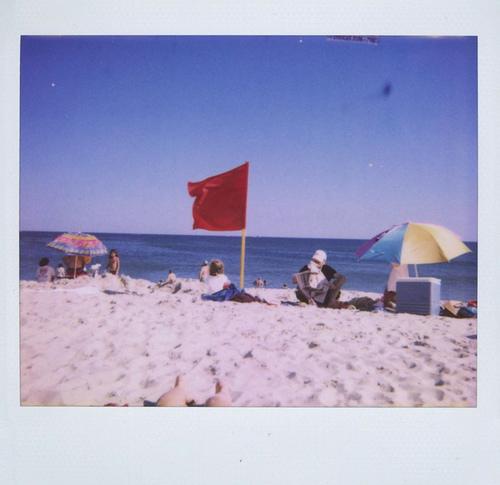Is this area in a market?
Answer briefly. No. Where was this picture taken?
Answer briefly. Beach. Is the dog awake or asleep?
Answer briefly. Awake. What time of the day was this picture taken?
Keep it brief. Noon. Is there anyone in the ocean?
Quick response, please. Yes. What season is this picture taking place in?
Give a very brief answer. Summer. Is there any color in this photo?
Write a very short answer. Yes. How many umbrellas are there in this picture?
Be succinct. 2. 